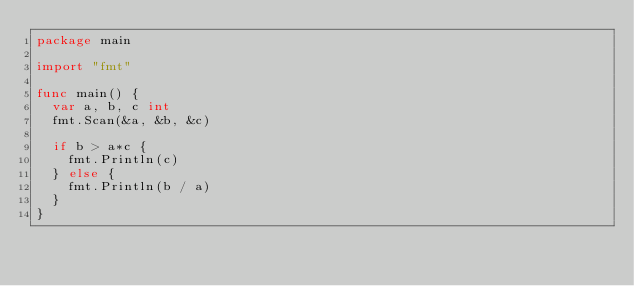<code> <loc_0><loc_0><loc_500><loc_500><_Go_>package main

import "fmt"

func main() {
	var a, b, c int
	fmt.Scan(&a, &b, &c)

	if b > a*c {
		fmt.Println(c)
	} else {
		fmt.Println(b / a)
	}
}
</code> 